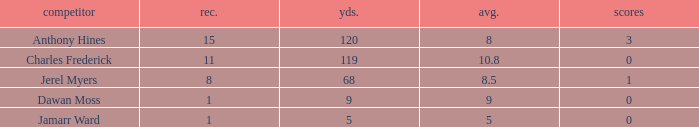What is the highest number of TDs when the Avg is larger than 8.5 and the Rec is less than 1? None. 